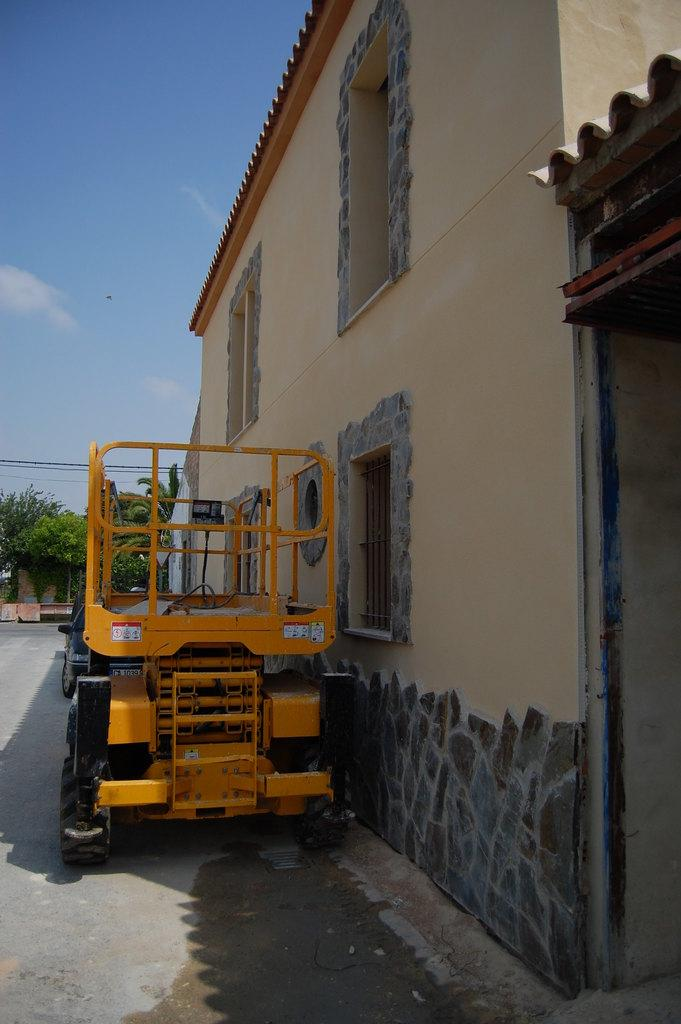What type of structures can be seen in the image? There are buildings in the image. What other natural elements are present in the image? There are trees in the image. What are some man-made objects visible in the image? There are vehicles parked in the image. What feature can be seen on the buildings and vehicles? There are windows visible in the image. How would you describe the weather in the image? The sky is blue and cloudy in the image. How many dogs are sitting on the glass office table in the image? There are no dogs or glass office tables present in the image. 